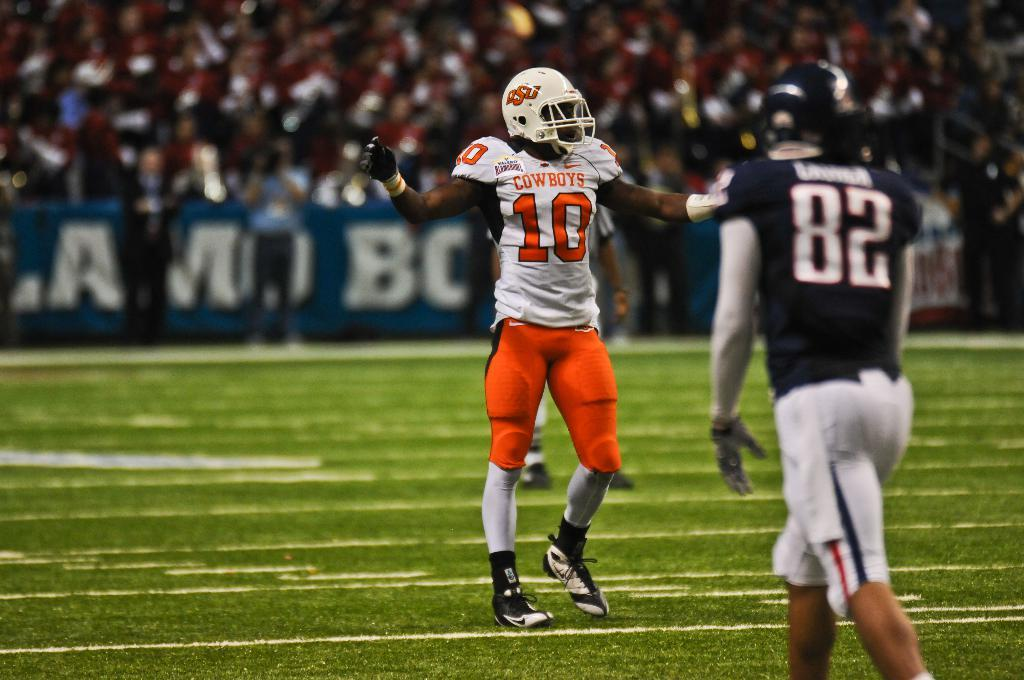Who or what can be seen in the image? There are people in the image. What are the people wearing? The people are wearing different color dresses. What can be seen in the background of the image? There are boards visible in the background. How is the background of the image depicted? The background is blurred. Are there any pests visible on the people's dresses in the image? There is no mention of pests in the provided facts, and therefore no such information can be determined from the image. Can you tell me how many icicles are hanging from the boards in the background? There is no mention of icicles in the provided facts, and therefore no such information can be determined from the image. 